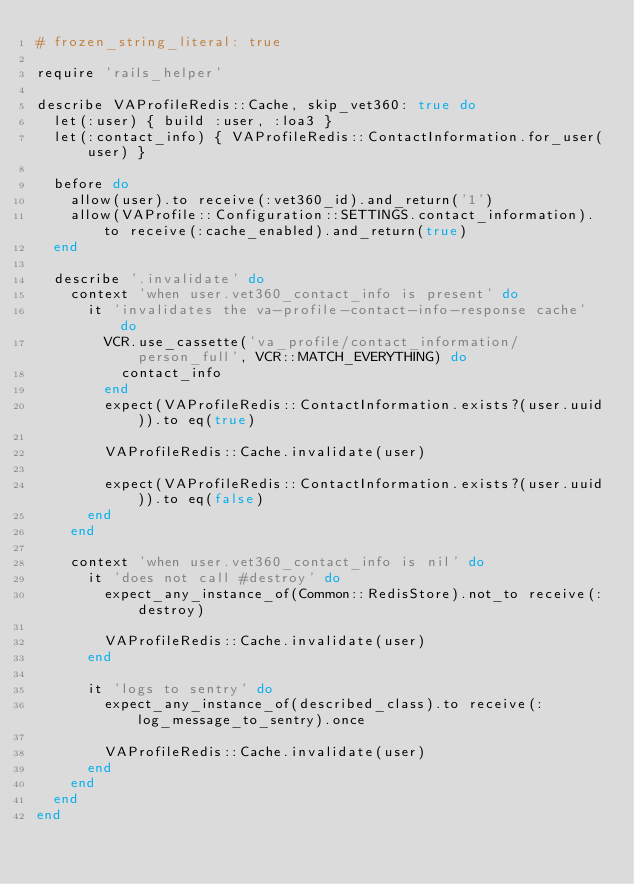Convert code to text. <code><loc_0><loc_0><loc_500><loc_500><_Ruby_># frozen_string_literal: true

require 'rails_helper'

describe VAProfileRedis::Cache, skip_vet360: true do
  let(:user) { build :user, :loa3 }
  let(:contact_info) { VAProfileRedis::ContactInformation.for_user(user) }

  before do
    allow(user).to receive(:vet360_id).and_return('1')
    allow(VAProfile::Configuration::SETTINGS.contact_information).to receive(:cache_enabled).and_return(true)
  end

  describe '.invalidate' do
    context 'when user.vet360_contact_info is present' do
      it 'invalidates the va-profile-contact-info-response cache' do
        VCR.use_cassette('va_profile/contact_information/person_full', VCR::MATCH_EVERYTHING) do
          contact_info
        end
        expect(VAProfileRedis::ContactInformation.exists?(user.uuid)).to eq(true)

        VAProfileRedis::Cache.invalidate(user)

        expect(VAProfileRedis::ContactInformation.exists?(user.uuid)).to eq(false)
      end
    end

    context 'when user.vet360_contact_info is nil' do
      it 'does not call #destroy' do
        expect_any_instance_of(Common::RedisStore).not_to receive(:destroy)

        VAProfileRedis::Cache.invalidate(user)
      end

      it 'logs to sentry' do
        expect_any_instance_of(described_class).to receive(:log_message_to_sentry).once

        VAProfileRedis::Cache.invalidate(user)
      end
    end
  end
end
</code> 